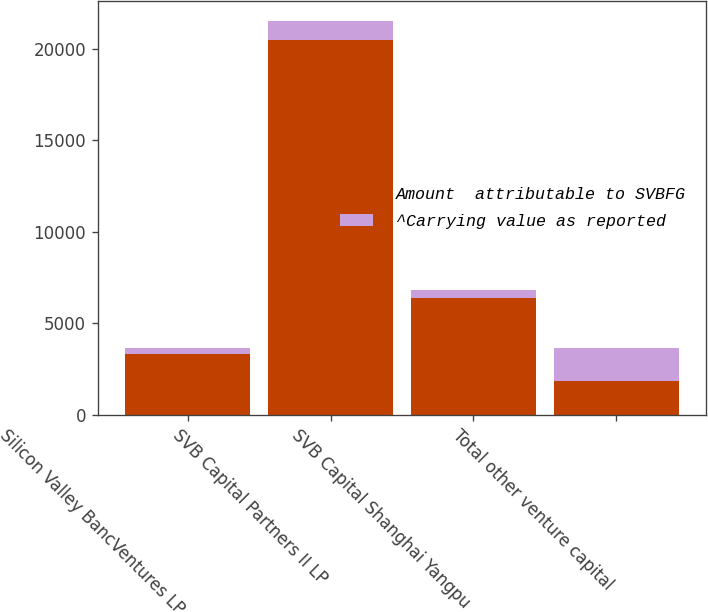Convert chart. <chart><loc_0><loc_0><loc_500><loc_500><stacked_bar_chart><ecel><fcel>Silicon Valley BancVentures LP<fcel>SVB Capital Partners II LP<fcel>SVB Capital Shanghai Yangpu<fcel>Total other venture capital<nl><fcel>Amount  attributable to SVBFG<fcel>3291<fcel>20481<fcel>6377<fcel>1823<nl><fcel>^Carrying value as reported<fcel>352<fcel>1040<fcel>431<fcel>1823<nl></chart> 